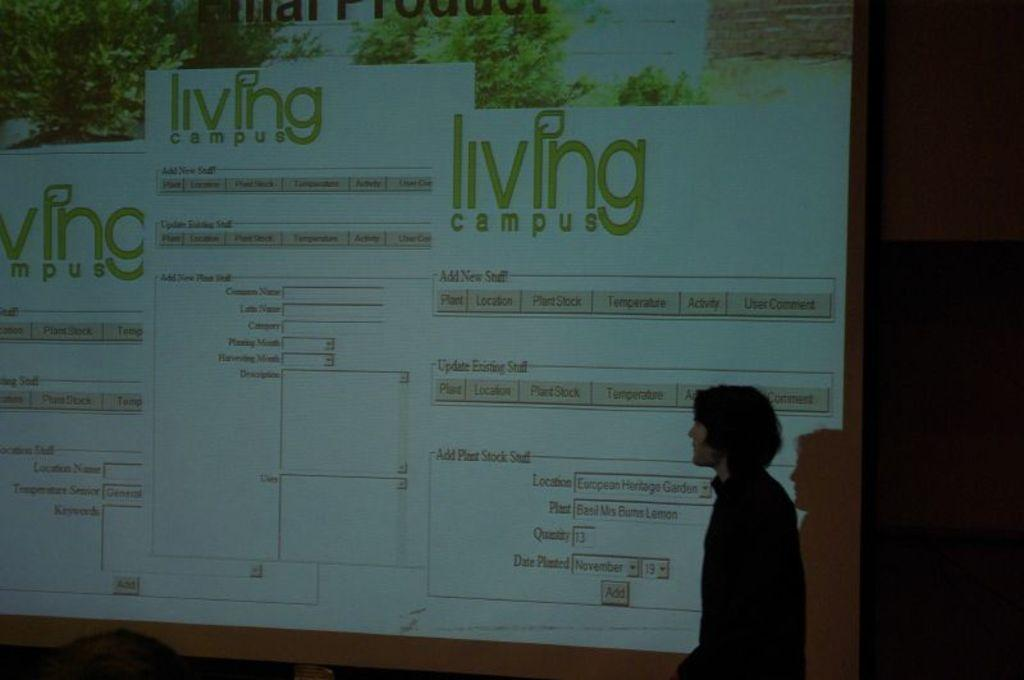<image>
Render a clear and concise summary of the photo. A person presenting a Living Campus on a projection screen. 